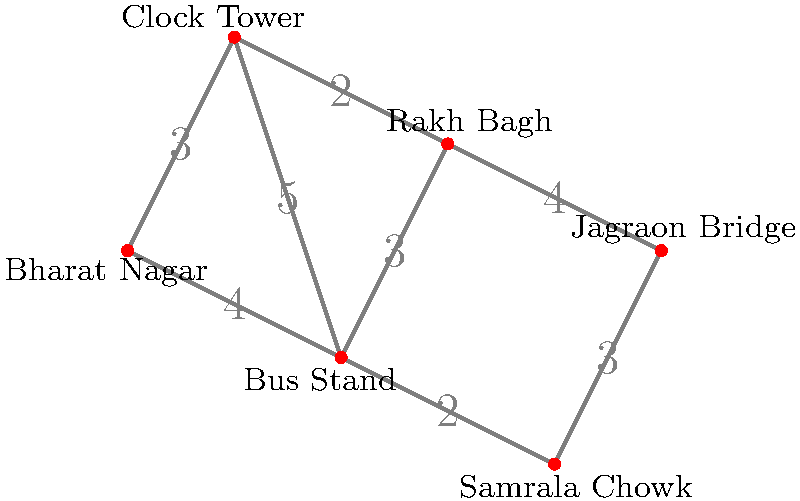Using the city map graph of Ludhiana, find the shortest route from Bharat Nagar to Jagraon Bridge. What is the total distance of this route? To find the shortest route from Bharat Nagar to Jagraon Bridge, we'll use Dijkstra's algorithm:

1. Start at Bharat Nagar (source).
2. Initialize distances: Bharat Nagar (0), others (infinity).
3. Visit unvisited vertex with smallest distance:
   a. Bharat Nagar (0):
      - Update Bus Stand: 4
      - Update Clock Tower: 3
   b. Clock Tower (3):
      - Update Rakh Bagh: 3 + 2 = 5
      - Bus Stand remains 4
   c. Bus Stand (4):
      - Update Samrala Chowk: 4 + 2 = 6
   d. Rakh Bagh (5):
      - Update Jagraon Bridge: 5 + 4 = 9
   e. Samrala Chowk (6):
      - Update Jagraon Bridge: 6 + 3 = 9

4. Shortest path: Bharat Nagar → Clock Tower → Rakh Bagh → Jagraon Bridge
5. Total distance: 3 + 2 + 4 = 9 km
Answer: 9 km 